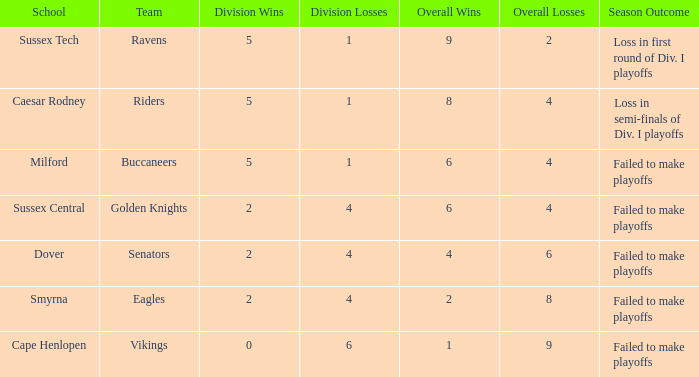What is the Overall Record for the School in Milford? 6 - 4. 